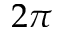<formula> <loc_0><loc_0><loc_500><loc_500>2 \pi</formula> 